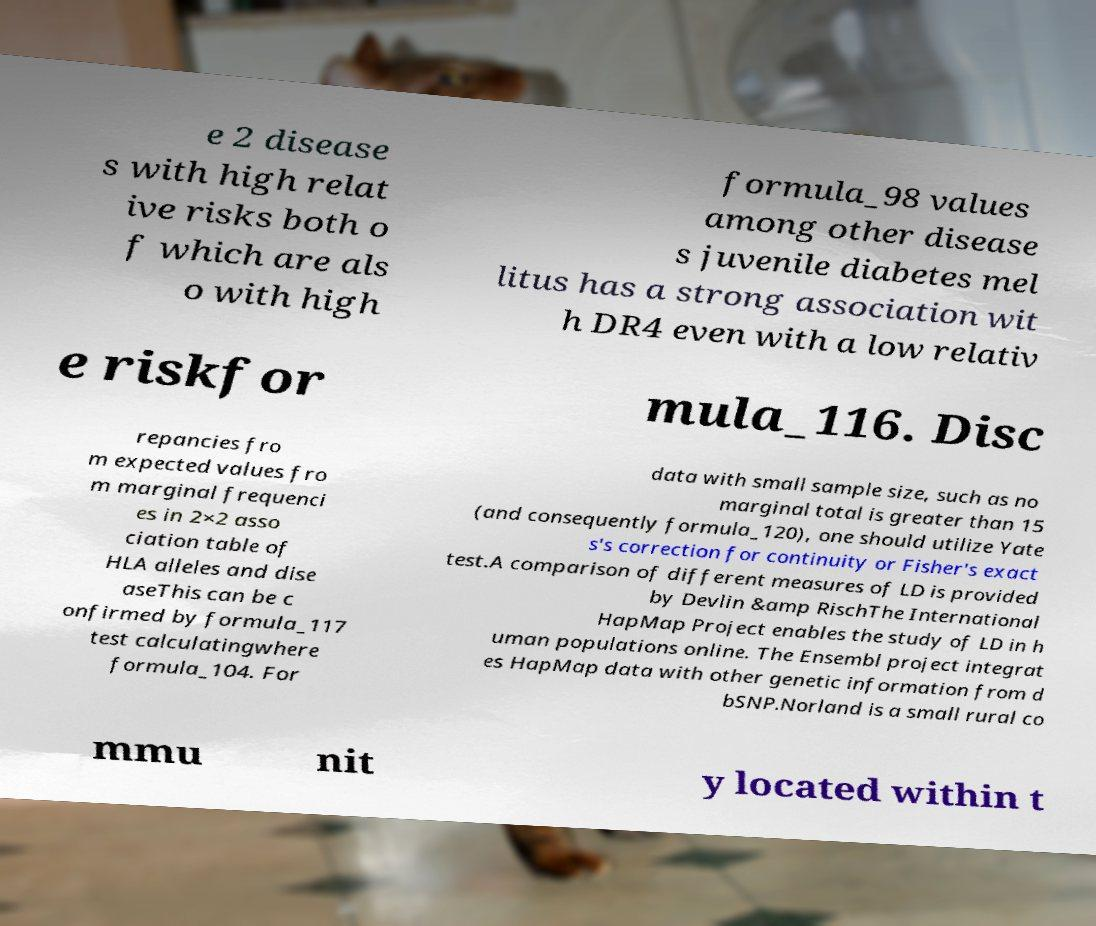Could you assist in decoding the text presented in this image and type it out clearly? e 2 disease s with high relat ive risks both o f which are als o with high formula_98 values among other disease s juvenile diabetes mel litus has a strong association wit h DR4 even with a low relativ e riskfor mula_116. Disc repancies fro m expected values fro m marginal frequenci es in 2×2 asso ciation table of HLA alleles and dise aseThis can be c onfirmed by formula_117 test calculatingwhere formula_104. For data with small sample size, such as no marginal total is greater than 15 (and consequently formula_120), one should utilize Yate s's correction for continuity or Fisher's exact test.A comparison of different measures of LD is provided by Devlin &amp RischThe International HapMap Project enables the study of LD in h uman populations online. The Ensembl project integrat es HapMap data with other genetic information from d bSNP.Norland is a small rural co mmu nit y located within t 